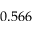<formula> <loc_0><loc_0><loc_500><loc_500>0 . 5 6 6</formula> 